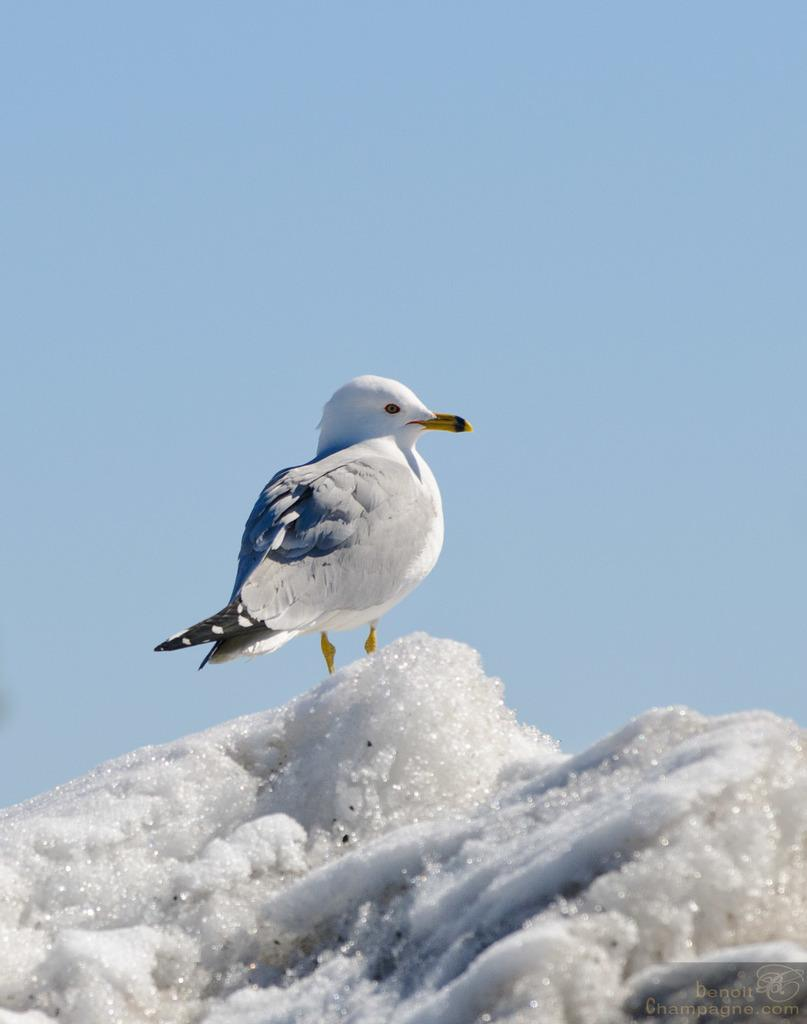What type of animal is in the image? There is a bird in the image. Where is the bird located? The bird is on the snow. Is there any text or marking in the image? Yes, there is a watermark at the right bottom of the image. What type of rice is being compared to the bird in the image? There is no rice present in the image, and no comparison is being made between the bird and any type of rice. 